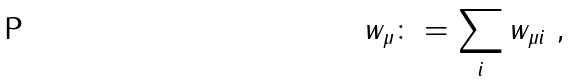<formula> <loc_0><loc_0><loc_500><loc_500>w _ { \mu } \colon = \sum _ { i } w _ { \mu i } \ ,</formula> 